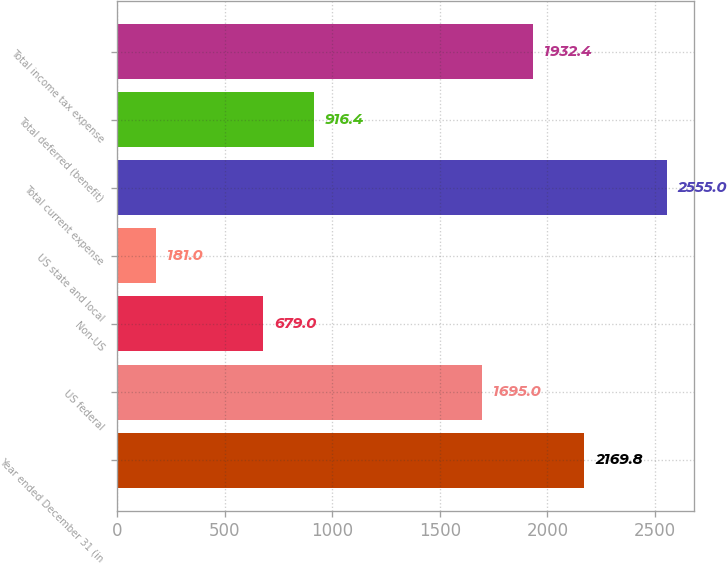<chart> <loc_0><loc_0><loc_500><loc_500><bar_chart><fcel>Year ended December 31 (in<fcel>US federal<fcel>Non-US<fcel>US state and local<fcel>Total current expense<fcel>Total deferred (benefit)<fcel>Total income tax expense<nl><fcel>2169.8<fcel>1695<fcel>679<fcel>181<fcel>2555<fcel>916.4<fcel>1932.4<nl></chart> 